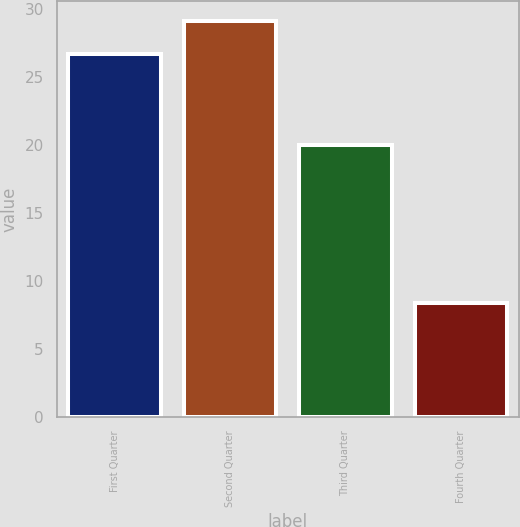<chart> <loc_0><loc_0><loc_500><loc_500><bar_chart><fcel>First Quarter<fcel>Second Quarter<fcel>Third Quarter<fcel>Fourth Quarter<nl><fcel>26.64<fcel>29.09<fcel>19.97<fcel>8.37<nl></chart> 